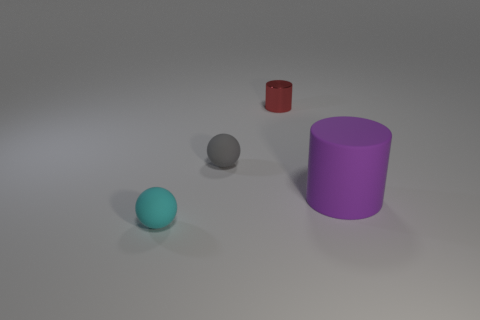Subtract all gray spheres. How many spheres are left? 1 Subtract 1 cylinders. How many cylinders are left? 1 Subtract all gray cubes. How many gray spheres are left? 1 Subtract all cyan matte things. Subtract all green shiny things. How many objects are left? 3 Add 3 tiny red shiny cylinders. How many tiny red shiny cylinders are left? 4 Add 2 metallic objects. How many metallic objects exist? 3 Add 1 small matte objects. How many objects exist? 5 Subtract 0 purple balls. How many objects are left? 4 Subtract all gray spheres. Subtract all blue blocks. How many spheres are left? 1 